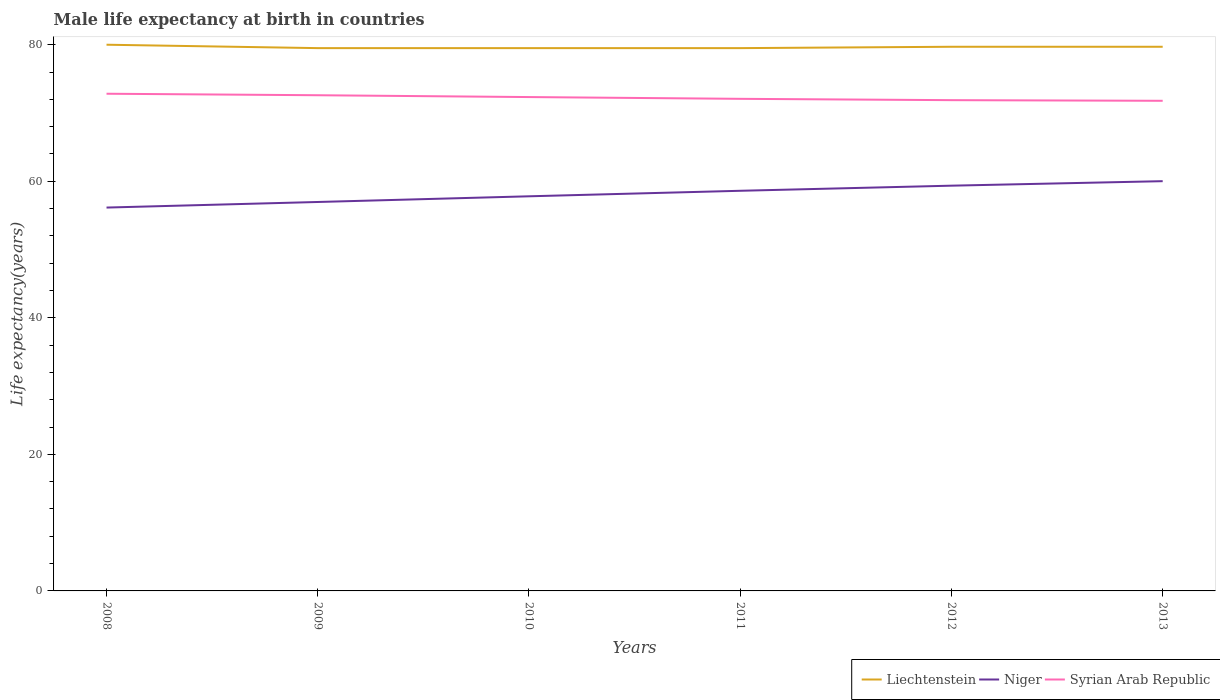How many different coloured lines are there?
Your answer should be very brief. 3. Across all years, what is the maximum male life expectancy at birth in Syrian Arab Republic?
Provide a short and direct response. 71.79. What is the total male life expectancy at birth in Liechtenstein in the graph?
Your response must be concise. 0. What is the difference between the highest and the second highest male life expectancy at birth in Niger?
Offer a terse response. 3.87. What is the difference between the highest and the lowest male life expectancy at birth in Niger?
Give a very brief answer. 3. Is the male life expectancy at birth in Syrian Arab Republic strictly greater than the male life expectancy at birth in Niger over the years?
Keep it short and to the point. No. How many lines are there?
Give a very brief answer. 3. Are the values on the major ticks of Y-axis written in scientific E-notation?
Ensure brevity in your answer.  No. Does the graph contain any zero values?
Provide a short and direct response. No. Does the graph contain grids?
Make the answer very short. No. What is the title of the graph?
Make the answer very short. Male life expectancy at birth in countries. Does "Namibia" appear as one of the legend labels in the graph?
Your answer should be very brief. No. What is the label or title of the X-axis?
Your answer should be compact. Years. What is the label or title of the Y-axis?
Your response must be concise. Life expectancy(years). What is the Life expectancy(years) in Liechtenstein in 2008?
Provide a succinct answer. 80. What is the Life expectancy(years) in Niger in 2008?
Offer a terse response. 56.15. What is the Life expectancy(years) in Syrian Arab Republic in 2008?
Provide a succinct answer. 72.82. What is the Life expectancy(years) of Liechtenstein in 2009?
Offer a terse response. 79.5. What is the Life expectancy(years) of Niger in 2009?
Offer a very short reply. 56.97. What is the Life expectancy(years) in Syrian Arab Republic in 2009?
Make the answer very short. 72.6. What is the Life expectancy(years) in Liechtenstein in 2010?
Your response must be concise. 79.5. What is the Life expectancy(years) of Niger in 2010?
Your response must be concise. 57.8. What is the Life expectancy(years) in Syrian Arab Republic in 2010?
Provide a short and direct response. 72.33. What is the Life expectancy(years) of Liechtenstein in 2011?
Make the answer very short. 79.5. What is the Life expectancy(years) in Niger in 2011?
Give a very brief answer. 58.61. What is the Life expectancy(years) in Syrian Arab Republic in 2011?
Provide a succinct answer. 72.07. What is the Life expectancy(years) in Liechtenstein in 2012?
Offer a terse response. 79.7. What is the Life expectancy(years) in Niger in 2012?
Offer a terse response. 59.35. What is the Life expectancy(years) of Syrian Arab Republic in 2012?
Provide a succinct answer. 71.88. What is the Life expectancy(years) in Liechtenstein in 2013?
Give a very brief answer. 79.7. What is the Life expectancy(years) of Niger in 2013?
Provide a succinct answer. 60.01. What is the Life expectancy(years) of Syrian Arab Republic in 2013?
Keep it short and to the point. 71.79. Across all years, what is the maximum Life expectancy(years) in Liechtenstein?
Offer a very short reply. 80. Across all years, what is the maximum Life expectancy(years) of Niger?
Make the answer very short. 60.01. Across all years, what is the maximum Life expectancy(years) in Syrian Arab Republic?
Your response must be concise. 72.82. Across all years, what is the minimum Life expectancy(years) in Liechtenstein?
Ensure brevity in your answer.  79.5. Across all years, what is the minimum Life expectancy(years) in Niger?
Give a very brief answer. 56.15. Across all years, what is the minimum Life expectancy(years) of Syrian Arab Republic?
Make the answer very short. 71.79. What is the total Life expectancy(years) of Liechtenstein in the graph?
Offer a very short reply. 477.9. What is the total Life expectancy(years) in Niger in the graph?
Provide a succinct answer. 348.89. What is the total Life expectancy(years) of Syrian Arab Republic in the graph?
Provide a succinct answer. 433.49. What is the difference between the Life expectancy(years) in Liechtenstein in 2008 and that in 2009?
Provide a short and direct response. 0.5. What is the difference between the Life expectancy(years) of Niger in 2008 and that in 2009?
Your answer should be compact. -0.82. What is the difference between the Life expectancy(years) in Syrian Arab Republic in 2008 and that in 2009?
Ensure brevity in your answer.  0.22. What is the difference between the Life expectancy(years) of Liechtenstein in 2008 and that in 2010?
Offer a very short reply. 0.5. What is the difference between the Life expectancy(years) of Niger in 2008 and that in 2010?
Make the answer very short. -1.65. What is the difference between the Life expectancy(years) in Syrian Arab Republic in 2008 and that in 2010?
Provide a succinct answer. 0.49. What is the difference between the Life expectancy(years) of Liechtenstein in 2008 and that in 2011?
Ensure brevity in your answer.  0.5. What is the difference between the Life expectancy(years) in Niger in 2008 and that in 2011?
Your answer should be very brief. -2.46. What is the difference between the Life expectancy(years) in Syrian Arab Republic in 2008 and that in 2011?
Your answer should be very brief. 0.75. What is the difference between the Life expectancy(years) in Liechtenstein in 2008 and that in 2012?
Your response must be concise. 0.3. What is the difference between the Life expectancy(years) in Niger in 2008 and that in 2012?
Provide a succinct answer. -3.21. What is the difference between the Life expectancy(years) of Syrian Arab Republic in 2008 and that in 2012?
Give a very brief answer. 0.94. What is the difference between the Life expectancy(years) of Niger in 2008 and that in 2013?
Offer a very short reply. -3.87. What is the difference between the Life expectancy(years) of Syrian Arab Republic in 2008 and that in 2013?
Your response must be concise. 1.03. What is the difference between the Life expectancy(years) in Liechtenstein in 2009 and that in 2010?
Offer a terse response. 0. What is the difference between the Life expectancy(years) of Niger in 2009 and that in 2010?
Your response must be concise. -0.83. What is the difference between the Life expectancy(years) in Syrian Arab Republic in 2009 and that in 2010?
Ensure brevity in your answer.  0.27. What is the difference between the Life expectancy(years) in Liechtenstein in 2009 and that in 2011?
Give a very brief answer. 0. What is the difference between the Life expectancy(years) of Niger in 2009 and that in 2011?
Your answer should be very brief. -1.64. What is the difference between the Life expectancy(years) of Syrian Arab Republic in 2009 and that in 2011?
Provide a succinct answer. 0.53. What is the difference between the Life expectancy(years) in Niger in 2009 and that in 2012?
Offer a very short reply. -2.39. What is the difference between the Life expectancy(years) of Syrian Arab Republic in 2009 and that in 2012?
Provide a short and direct response. 0.72. What is the difference between the Life expectancy(years) of Niger in 2009 and that in 2013?
Your answer should be very brief. -3.05. What is the difference between the Life expectancy(years) in Syrian Arab Republic in 2009 and that in 2013?
Your answer should be compact. 0.81. What is the difference between the Life expectancy(years) of Niger in 2010 and that in 2011?
Make the answer very short. -0.81. What is the difference between the Life expectancy(years) in Syrian Arab Republic in 2010 and that in 2011?
Make the answer very short. 0.26. What is the difference between the Life expectancy(years) in Niger in 2010 and that in 2012?
Your answer should be compact. -1.55. What is the difference between the Life expectancy(years) of Syrian Arab Republic in 2010 and that in 2012?
Offer a terse response. 0.45. What is the difference between the Life expectancy(years) in Niger in 2010 and that in 2013?
Keep it short and to the point. -2.21. What is the difference between the Life expectancy(years) of Syrian Arab Republic in 2010 and that in 2013?
Make the answer very short. 0.55. What is the difference between the Life expectancy(years) in Niger in 2011 and that in 2012?
Make the answer very short. -0.75. What is the difference between the Life expectancy(years) in Syrian Arab Republic in 2011 and that in 2012?
Make the answer very short. 0.2. What is the difference between the Life expectancy(years) in Niger in 2011 and that in 2013?
Offer a terse response. -1.41. What is the difference between the Life expectancy(years) of Syrian Arab Republic in 2011 and that in 2013?
Provide a short and direct response. 0.29. What is the difference between the Life expectancy(years) in Niger in 2012 and that in 2013?
Your answer should be compact. -0.66. What is the difference between the Life expectancy(years) of Syrian Arab Republic in 2012 and that in 2013?
Your answer should be compact. 0.09. What is the difference between the Life expectancy(years) in Liechtenstein in 2008 and the Life expectancy(years) in Niger in 2009?
Your answer should be compact. 23.03. What is the difference between the Life expectancy(years) in Liechtenstein in 2008 and the Life expectancy(years) in Syrian Arab Republic in 2009?
Your answer should be very brief. 7.4. What is the difference between the Life expectancy(years) in Niger in 2008 and the Life expectancy(years) in Syrian Arab Republic in 2009?
Your answer should be compact. -16.45. What is the difference between the Life expectancy(years) in Liechtenstein in 2008 and the Life expectancy(years) in Niger in 2010?
Give a very brief answer. 22.2. What is the difference between the Life expectancy(years) in Liechtenstein in 2008 and the Life expectancy(years) in Syrian Arab Republic in 2010?
Offer a terse response. 7.67. What is the difference between the Life expectancy(years) of Niger in 2008 and the Life expectancy(years) of Syrian Arab Republic in 2010?
Your response must be concise. -16.18. What is the difference between the Life expectancy(years) in Liechtenstein in 2008 and the Life expectancy(years) in Niger in 2011?
Keep it short and to the point. 21.39. What is the difference between the Life expectancy(years) in Liechtenstein in 2008 and the Life expectancy(years) in Syrian Arab Republic in 2011?
Provide a succinct answer. 7.93. What is the difference between the Life expectancy(years) of Niger in 2008 and the Life expectancy(years) of Syrian Arab Republic in 2011?
Your answer should be compact. -15.93. What is the difference between the Life expectancy(years) of Liechtenstein in 2008 and the Life expectancy(years) of Niger in 2012?
Provide a short and direct response. 20.65. What is the difference between the Life expectancy(years) in Liechtenstein in 2008 and the Life expectancy(years) in Syrian Arab Republic in 2012?
Your answer should be compact. 8.12. What is the difference between the Life expectancy(years) in Niger in 2008 and the Life expectancy(years) in Syrian Arab Republic in 2012?
Your answer should be very brief. -15.73. What is the difference between the Life expectancy(years) in Liechtenstein in 2008 and the Life expectancy(years) in Niger in 2013?
Your answer should be very brief. 19.99. What is the difference between the Life expectancy(years) of Liechtenstein in 2008 and the Life expectancy(years) of Syrian Arab Republic in 2013?
Provide a short and direct response. 8.21. What is the difference between the Life expectancy(years) in Niger in 2008 and the Life expectancy(years) in Syrian Arab Republic in 2013?
Offer a very short reply. -15.64. What is the difference between the Life expectancy(years) in Liechtenstein in 2009 and the Life expectancy(years) in Niger in 2010?
Give a very brief answer. 21.7. What is the difference between the Life expectancy(years) in Liechtenstein in 2009 and the Life expectancy(years) in Syrian Arab Republic in 2010?
Your answer should be very brief. 7.17. What is the difference between the Life expectancy(years) in Niger in 2009 and the Life expectancy(years) in Syrian Arab Republic in 2010?
Provide a short and direct response. -15.37. What is the difference between the Life expectancy(years) in Liechtenstein in 2009 and the Life expectancy(years) in Niger in 2011?
Offer a very short reply. 20.89. What is the difference between the Life expectancy(years) of Liechtenstein in 2009 and the Life expectancy(years) of Syrian Arab Republic in 2011?
Your response must be concise. 7.43. What is the difference between the Life expectancy(years) of Niger in 2009 and the Life expectancy(years) of Syrian Arab Republic in 2011?
Give a very brief answer. -15.11. What is the difference between the Life expectancy(years) in Liechtenstein in 2009 and the Life expectancy(years) in Niger in 2012?
Provide a succinct answer. 20.15. What is the difference between the Life expectancy(years) in Liechtenstein in 2009 and the Life expectancy(years) in Syrian Arab Republic in 2012?
Make the answer very short. 7.62. What is the difference between the Life expectancy(years) of Niger in 2009 and the Life expectancy(years) of Syrian Arab Republic in 2012?
Give a very brief answer. -14.91. What is the difference between the Life expectancy(years) in Liechtenstein in 2009 and the Life expectancy(years) in Niger in 2013?
Your answer should be compact. 19.49. What is the difference between the Life expectancy(years) of Liechtenstein in 2009 and the Life expectancy(years) of Syrian Arab Republic in 2013?
Your answer should be very brief. 7.71. What is the difference between the Life expectancy(years) in Niger in 2009 and the Life expectancy(years) in Syrian Arab Republic in 2013?
Offer a very short reply. -14.82. What is the difference between the Life expectancy(years) of Liechtenstein in 2010 and the Life expectancy(years) of Niger in 2011?
Ensure brevity in your answer.  20.89. What is the difference between the Life expectancy(years) of Liechtenstein in 2010 and the Life expectancy(years) of Syrian Arab Republic in 2011?
Provide a succinct answer. 7.43. What is the difference between the Life expectancy(years) in Niger in 2010 and the Life expectancy(years) in Syrian Arab Republic in 2011?
Your response must be concise. -14.28. What is the difference between the Life expectancy(years) in Liechtenstein in 2010 and the Life expectancy(years) in Niger in 2012?
Offer a very short reply. 20.15. What is the difference between the Life expectancy(years) of Liechtenstein in 2010 and the Life expectancy(years) of Syrian Arab Republic in 2012?
Give a very brief answer. 7.62. What is the difference between the Life expectancy(years) of Niger in 2010 and the Life expectancy(years) of Syrian Arab Republic in 2012?
Give a very brief answer. -14.08. What is the difference between the Life expectancy(years) of Liechtenstein in 2010 and the Life expectancy(years) of Niger in 2013?
Offer a terse response. 19.49. What is the difference between the Life expectancy(years) in Liechtenstein in 2010 and the Life expectancy(years) in Syrian Arab Republic in 2013?
Provide a succinct answer. 7.71. What is the difference between the Life expectancy(years) in Niger in 2010 and the Life expectancy(years) in Syrian Arab Republic in 2013?
Offer a very short reply. -13.99. What is the difference between the Life expectancy(years) of Liechtenstein in 2011 and the Life expectancy(years) of Niger in 2012?
Offer a terse response. 20.15. What is the difference between the Life expectancy(years) in Liechtenstein in 2011 and the Life expectancy(years) in Syrian Arab Republic in 2012?
Provide a succinct answer. 7.62. What is the difference between the Life expectancy(years) of Niger in 2011 and the Life expectancy(years) of Syrian Arab Republic in 2012?
Provide a succinct answer. -13.27. What is the difference between the Life expectancy(years) of Liechtenstein in 2011 and the Life expectancy(years) of Niger in 2013?
Your response must be concise. 19.49. What is the difference between the Life expectancy(years) of Liechtenstein in 2011 and the Life expectancy(years) of Syrian Arab Republic in 2013?
Ensure brevity in your answer.  7.71. What is the difference between the Life expectancy(years) in Niger in 2011 and the Life expectancy(years) in Syrian Arab Republic in 2013?
Give a very brief answer. -13.18. What is the difference between the Life expectancy(years) of Liechtenstein in 2012 and the Life expectancy(years) of Niger in 2013?
Make the answer very short. 19.69. What is the difference between the Life expectancy(years) of Liechtenstein in 2012 and the Life expectancy(years) of Syrian Arab Republic in 2013?
Give a very brief answer. 7.91. What is the difference between the Life expectancy(years) in Niger in 2012 and the Life expectancy(years) in Syrian Arab Republic in 2013?
Offer a terse response. -12.43. What is the average Life expectancy(years) in Liechtenstein per year?
Keep it short and to the point. 79.65. What is the average Life expectancy(years) of Niger per year?
Your answer should be very brief. 58.15. What is the average Life expectancy(years) of Syrian Arab Republic per year?
Keep it short and to the point. 72.25. In the year 2008, what is the difference between the Life expectancy(years) of Liechtenstein and Life expectancy(years) of Niger?
Give a very brief answer. 23.85. In the year 2008, what is the difference between the Life expectancy(years) in Liechtenstein and Life expectancy(years) in Syrian Arab Republic?
Make the answer very short. 7.18. In the year 2008, what is the difference between the Life expectancy(years) in Niger and Life expectancy(years) in Syrian Arab Republic?
Offer a very short reply. -16.67. In the year 2009, what is the difference between the Life expectancy(years) in Liechtenstein and Life expectancy(years) in Niger?
Give a very brief answer. 22.53. In the year 2009, what is the difference between the Life expectancy(years) in Liechtenstein and Life expectancy(years) in Syrian Arab Republic?
Your response must be concise. 6.9. In the year 2009, what is the difference between the Life expectancy(years) in Niger and Life expectancy(years) in Syrian Arab Republic?
Provide a short and direct response. -15.63. In the year 2010, what is the difference between the Life expectancy(years) in Liechtenstein and Life expectancy(years) in Niger?
Make the answer very short. 21.7. In the year 2010, what is the difference between the Life expectancy(years) in Liechtenstein and Life expectancy(years) in Syrian Arab Republic?
Ensure brevity in your answer.  7.17. In the year 2010, what is the difference between the Life expectancy(years) in Niger and Life expectancy(years) in Syrian Arab Republic?
Your response must be concise. -14.53. In the year 2011, what is the difference between the Life expectancy(years) of Liechtenstein and Life expectancy(years) of Niger?
Your response must be concise. 20.89. In the year 2011, what is the difference between the Life expectancy(years) in Liechtenstein and Life expectancy(years) in Syrian Arab Republic?
Give a very brief answer. 7.43. In the year 2011, what is the difference between the Life expectancy(years) in Niger and Life expectancy(years) in Syrian Arab Republic?
Offer a terse response. -13.47. In the year 2012, what is the difference between the Life expectancy(years) in Liechtenstein and Life expectancy(years) in Niger?
Your answer should be compact. 20.35. In the year 2012, what is the difference between the Life expectancy(years) of Liechtenstein and Life expectancy(years) of Syrian Arab Republic?
Provide a succinct answer. 7.82. In the year 2012, what is the difference between the Life expectancy(years) in Niger and Life expectancy(years) in Syrian Arab Republic?
Provide a short and direct response. -12.53. In the year 2013, what is the difference between the Life expectancy(years) in Liechtenstein and Life expectancy(years) in Niger?
Offer a terse response. 19.69. In the year 2013, what is the difference between the Life expectancy(years) of Liechtenstein and Life expectancy(years) of Syrian Arab Republic?
Your response must be concise. 7.91. In the year 2013, what is the difference between the Life expectancy(years) in Niger and Life expectancy(years) in Syrian Arab Republic?
Give a very brief answer. -11.77. What is the ratio of the Life expectancy(years) of Liechtenstein in 2008 to that in 2009?
Offer a very short reply. 1.01. What is the ratio of the Life expectancy(years) in Niger in 2008 to that in 2009?
Provide a short and direct response. 0.99. What is the ratio of the Life expectancy(years) in Syrian Arab Republic in 2008 to that in 2009?
Offer a very short reply. 1. What is the ratio of the Life expectancy(years) in Liechtenstein in 2008 to that in 2010?
Your answer should be very brief. 1.01. What is the ratio of the Life expectancy(years) in Niger in 2008 to that in 2010?
Offer a very short reply. 0.97. What is the ratio of the Life expectancy(years) of Liechtenstein in 2008 to that in 2011?
Provide a short and direct response. 1.01. What is the ratio of the Life expectancy(years) of Niger in 2008 to that in 2011?
Make the answer very short. 0.96. What is the ratio of the Life expectancy(years) in Syrian Arab Republic in 2008 to that in 2011?
Provide a short and direct response. 1.01. What is the ratio of the Life expectancy(years) in Niger in 2008 to that in 2012?
Keep it short and to the point. 0.95. What is the ratio of the Life expectancy(years) of Syrian Arab Republic in 2008 to that in 2012?
Your answer should be compact. 1.01. What is the ratio of the Life expectancy(years) in Niger in 2008 to that in 2013?
Make the answer very short. 0.94. What is the ratio of the Life expectancy(years) in Syrian Arab Republic in 2008 to that in 2013?
Your answer should be compact. 1.01. What is the ratio of the Life expectancy(years) of Liechtenstein in 2009 to that in 2010?
Provide a succinct answer. 1. What is the ratio of the Life expectancy(years) in Niger in 2009 to that in 2010?
Provide a succinct answer. 0.99. What is the ratio of the Life expectancy(years) in Syrian Arab Republic in 2009 to that in 2010?
Ensure brevity in your answer.  1. What is the ratio of the Life expectancy(years) of Liechtenstein in 2009 to that in 2011?
Your answer should be very brief. 1. What is the ratio of the Life expectancy(years) of Niger in 2009 to that in 2011?
Make the answer very short. 0.97. What is the ratio of the Life expectancy(years) in Syrian Arab Republic in 2009 to that in 2011?
Provide a short and direct response. 1.01. What is the ratio of the Life expectancy(years) of Liechtenstein in 2009 to that in 2012?
Ensure brevity in your answer.  1. What is the ratio of the Life expectancy(years) in Niger in 2009 to that in 2012?
Ensure brevity in your answer.  0.96. What is the ratio of the Life expectancy(years) of Syrian Arab Republic in 2009 to that in 2012?
Provide a short and direct response. 1.01. What is the ratio of the Life expectancy(years) in Niger in 2009 to that in 2013?
Give a very brief answer. 0.95. What is the ratio of the Life expectancy(years) of Syrian Arab Republic in 2009 to that in 2013?
Keep it short and to the point. 1.01. What is the ratio of the Life expectancy(years) in Niger in 2010 to that in 2011?
Offer a very short reply. 0.99. What is the ratio of the Life expectancy(years) in Liechtenstein in 2010 to that in 2012?
Provide a succinct answer. 1. What is the ratio of the Life expectancy(years) of Niger in 2010 to that in 2012?
Provide a succinct answer. 0.97. What is the ratio of the Life expectancy(years) in Syrian Arab Republic in 2010 to that in 2012?
Your answer should be very brief. 1.01. What is the ratio of the Life expectancy(years) in Liechtenstein in 2010 to that in 2013?
Your answer should be very brief. 1. What is the ratio of the Life expectancy(years) of Niger in 2010 to that in 2013?
Your response must be concise. 0.96. What is the ratio of the Life expectancy(years) in Syrian Arab Republic in 2010 to that in 2013?
Give a very brief answer. 1.01. What is the ratio of the Life expectancy(years) in Niger in 2011 to that in 2012?
Give a very brief answer. 0.99. What is the ratio of the Life expectancy(years) of Syrian Arab Republic in 2011 to that in 2012?
Your answer should be compact. 1. What is the ratio of the Life expectancy(years) of Niger in 2011 to that in 2013?
Provide a succinct answer. 0.98. What is the ratio of the Life expectancy(years) in Liechtenstein in 2012 to that in 2013?
Provide a succinct answer. 1. What is the ratio of the Life expectancy(years) in Niger in 2012 to that in 2013?
Your answer should be very brief. 0.99. What is the difference between the highest and the second highest Life expectancy(years) of Niger?
Keep it short and to the point. 0.66. What is the difference between the highest and the second highest Life expectancy(years) of Syrian Arab Republic?
Make the answer very short. 0.22. What is the difference between the highest and the lowest Life expectancy(years) in Liechtenstein?
Keep it short and to the point. 0.5. What is the difference between the highest and the lowest Life expectancy(years) of Niger?
Offer a terse response. 3.87. What is the difference between the highest and the lowest Life expectancy(years) in Syrian Arab Republic?
Give a very brief answer. 1.03. 